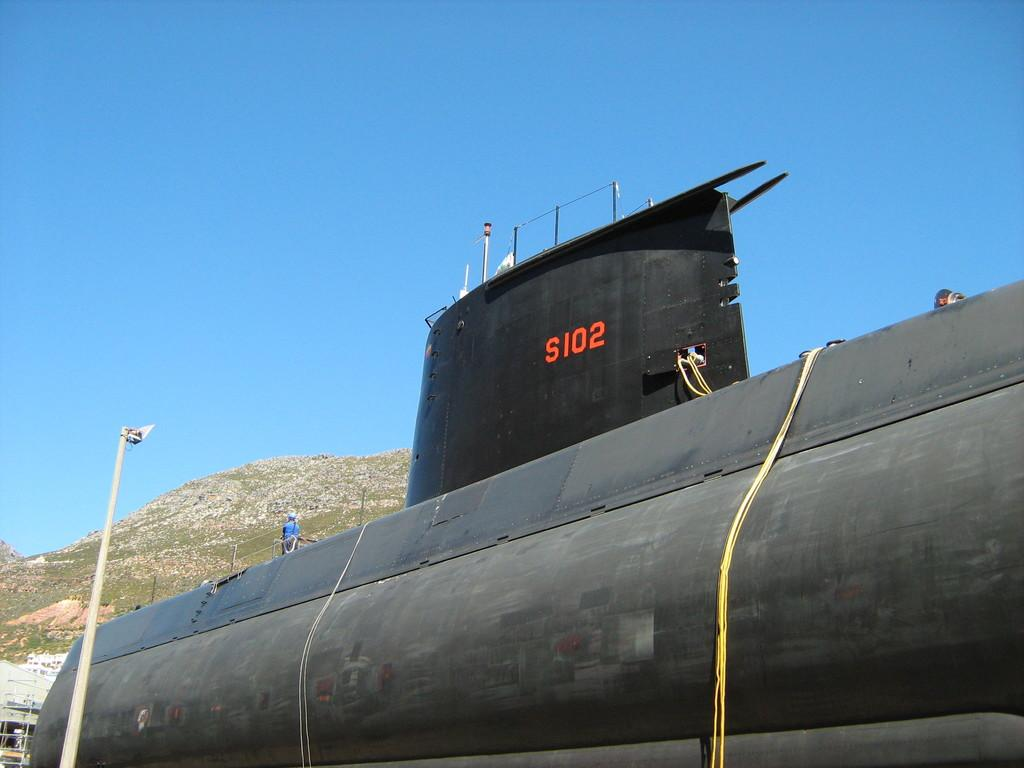What is the main subject of the image? The main subject of the image is a submarine. What can be seen on the submarine? There is text on the submarine. What other object is present in the image? There is a light pole in the image. What type of landscape is visible in the image? Hills are visible in the image. What part of the natural environment is visible in the image? The sky is visible in the image. What type of coal is being used to fuel the coach in the image? There is no coach or coal present in the image; it features a submarine and a light pole. How many people are taking a bath in the image? There is no bath or people taking a bath present in the image. 